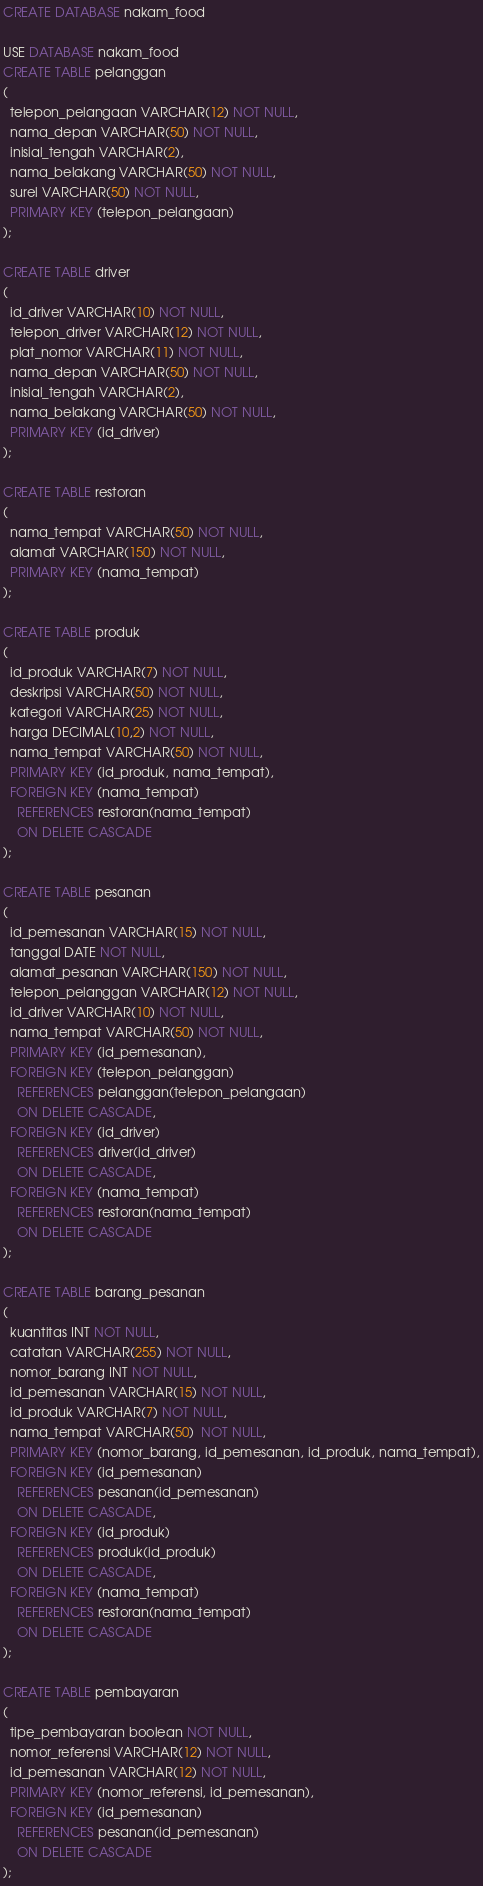Convert code to text. <code><loc_0><loc_0><loc_500><loc_500><_SQL_>CREATE DATABASE nakam_food

USE DATABASE nakam_food
CREATE TABLE pelanggan
(
  telepon_pelangaan VARCHAR(12) NOT NULL,
  nama_depan VARCHAR(50) NOT NULL,
  inisial_tengah VARCHAR(2),
  nama_belakang VARCHAR(50) NOT NULL,
  surel VARCHAR(50) NOT NULL,
  PRIMARY KEY (telepon_pelangaan)
);

CREATE TABLE driver
(
  id_driver VARCHAR(10) NOT NULL,
  telepon_driver VARCHAR(12) NOT NULL,
  plat_nomor VARCHAR(11) NOT NULL,
  nama_depan VARCHAR(50) NOT NULL,
  inisial_tengah VARCHAR(2),
  nama_belakang VARCHAR(50) NOT NULL,
  PRIMARY KEY (id_driver)
);

CREATE TABLE restoran
(
  nama_tempat VARCHAR(50) NOT NULL,
  alamat VARCHAR(150) NOT NULL,
  PRIMARY KEY (nama_tempat)
);

CREATE TABLE produk
(
  id_produk VARCHAR(7) NOT NULL,
  deskripsi VARCHAR(50) NOT NULL,
  kategori VARCHAR(25) NOT NULL,
  harga DECIMAL(10,2) NOT NULL,
  nama_tempat VARCHAR(50) NOT NULL,
  PRIMARY KEY (id_produk, nama_tempat),
  FOREIGN KEY (nama_tempat) 
    REFERENCES restoran(nama_tempat)
    ON DELETE CASCADE
);

CREATE TABLE pesanan
(
  id_pemesanan VARCHAR(15) NOT NULL,
  tanggal DATE NOT NULL,
  alamat_pesanan VARCHAR(150) NOT NULL,
  telepon_pelanggan VARCHAR(12) NOT NULL,
  id_driver VARCHAR(10) NOT NULL,
  nama_tempat VARCHAR(50) NOT NULL,
  PRIMARY KEY (id_pemesanan),
  FOREIGN KEY (telepon_pelanggan) 
    REFERENCES pelanggan(telepon_pelangaan)
    ON DELETE CASCADE,
  FOREIGN KEY (id_driver) 
    REFERENCES driver(id_driver)
    ON DELETE CASCADE,
  FOREIGN KEY (nama_tempat) 
    REFERENCES restoran(nama_tempat)
    ON DELETE CASCADE
);

CREATE TABLE barang_pesanan
(
  kuantitas INT NOT NULL,
  catatan VARCHAR(255) NOT NULL,
  nomor_barang INT NOT NULL,
  id_pemesanan VARCHAR(15) NOT NULL,
  id_produk VARCHAR(7) NOT NULL,
  nama_tempat VARCHAR(50)  NOT NULL,
  PRIMARY KEY (nomor_barang, id_pemesanan, id_produk, nama_tempat),
  FOREIGN KEY (id_pemesanan) 
    REFERENCES pesanan(id_pemesanan)
    ON DELETE CASCADE,
  FOREIGN KEY (id_produk) 
    REFERENCES produk(id_produk)
    ON DELETE CASCADE,
  FOREIGN KEY (nama_tempat) 
    REFERENCES restoran(nama_tempat)
    ON DELETE CASCADE
);

CREATE TABLE pembayaran
(
  tipe_pembayaran boolean NOT NULL,
  nomor_referensi VARCHAR(12) NOT NULL,
  id_pemesanan VARCHAR(12) NOT NULL,
  PRIMARY KEY (nomor_referensi, id_pemesanan),
  FOREIGN KEY (id_pemesanan) 
    REFERENCES pesanan(id_pemesanan)
    ON DELETE CASCADE
);
</code> 